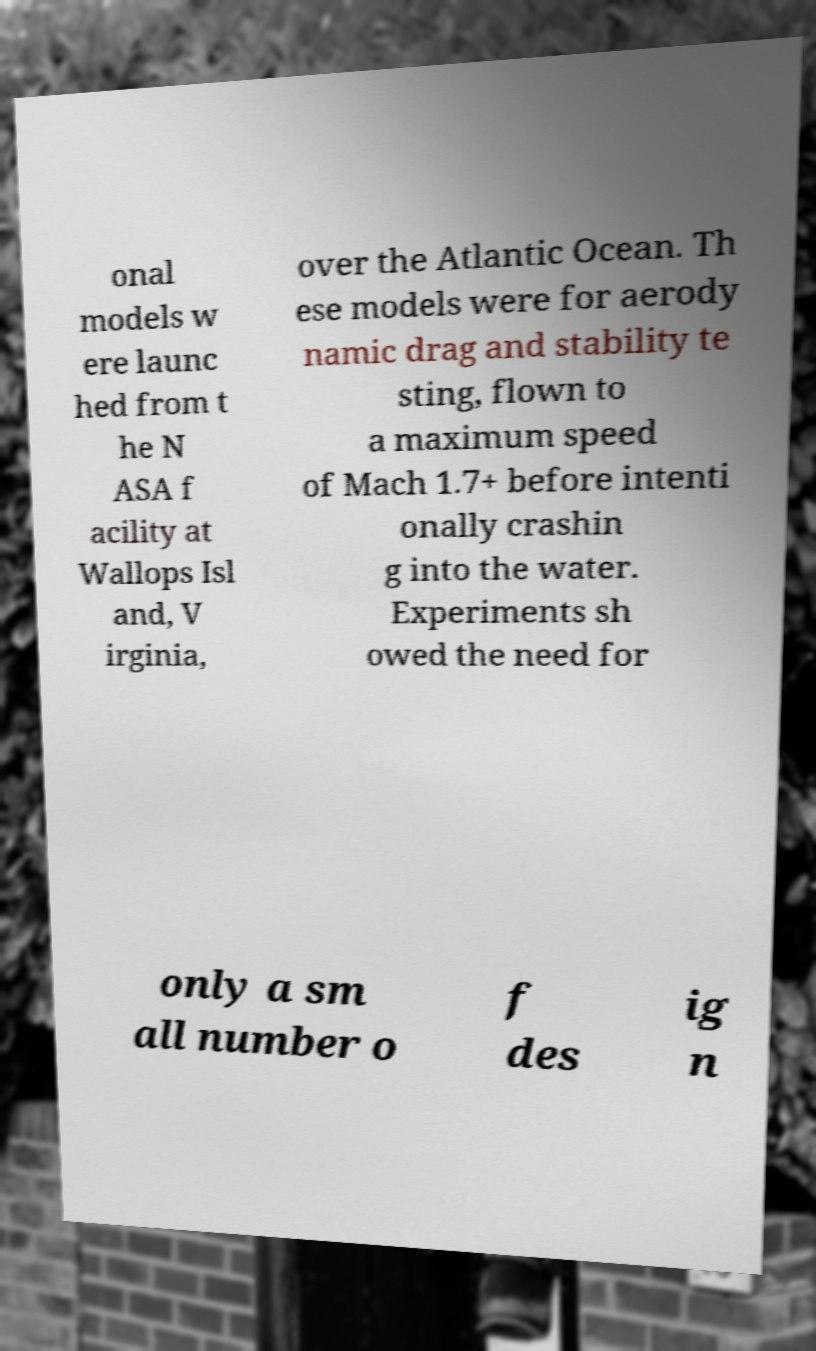What messages or text are displayed in this image? I need them in a readable, typed format. onal models w ere launc hed from t he N ASA f acility at Wallops Isl and, V irginia, over the Atlantic Ocean. Th ese models were for aerody namic drag and stability te sting, flown to a maximum speed of Mach 1.7+ before intenti onally crashin g into the water. Experiments sh owed the need for only a sm all number o f des ig n 